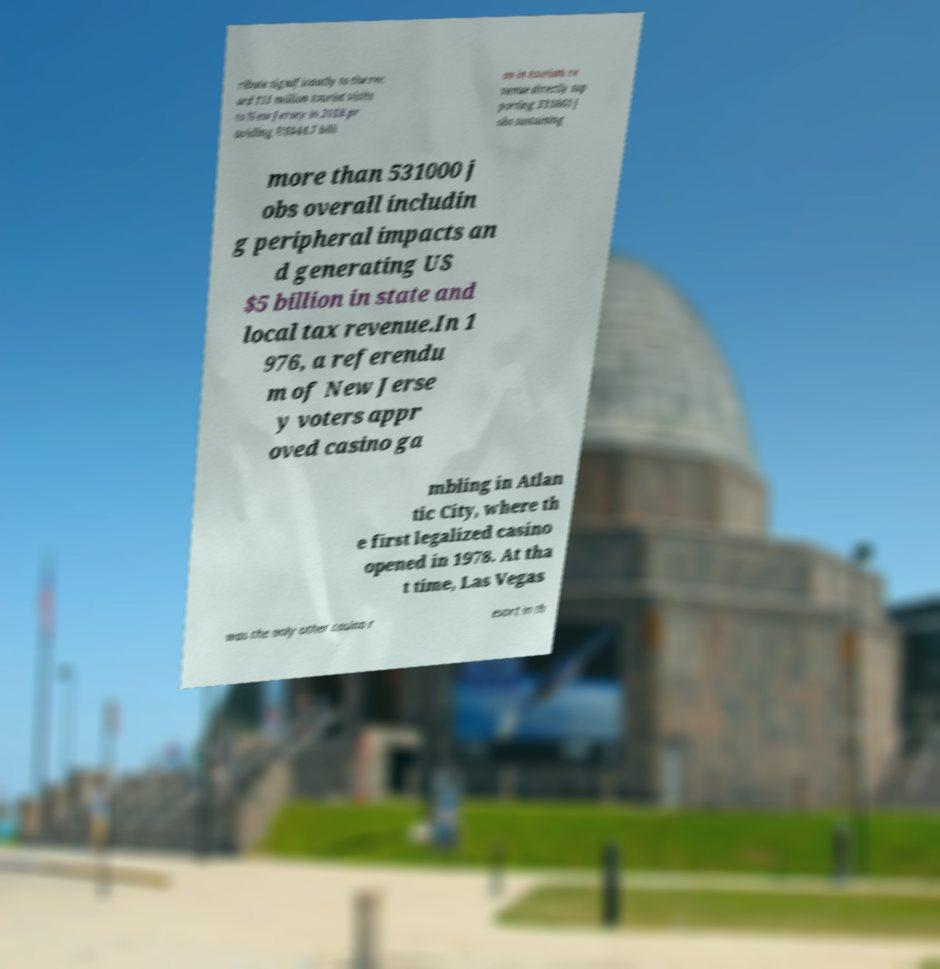Could you assist in decoding the text presented in this image and type it out clearly? ribute significantly to the rec ord 111 million tourist visits to New Jersey in 2018 pr oviding US$44.7 billi on in tourism re venue directly sup porting 333860 j obs sustaining more than 531000 j obs overall includin g peripheral impacts an d generating US $5 billion in state and local tax revenue.In 1 976, a referendu m of New Jerse y voters appr oved casino ga mbling in Atlan tic City, where th e first legalized casino opened in 1978. At tha t time, Las Vegas was the only other casino r esort in th 